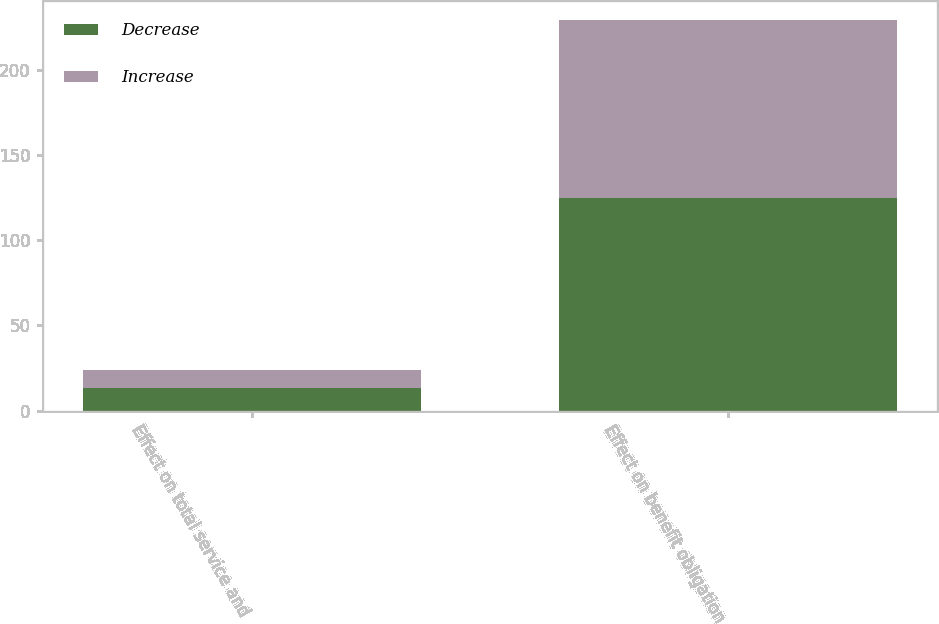Convert chart to OTSL. <chart><loc_0><loc_0><loc_500><loc_500><stacked_bar_chart><ecel><fcel>Effect on total service and<fcel>Effect on benefit obligation<nl><fcel>Decrease<fcel>13<fcel>125<nl><fcel>Increase<fcel>11<fcel>104<nl></chart> 